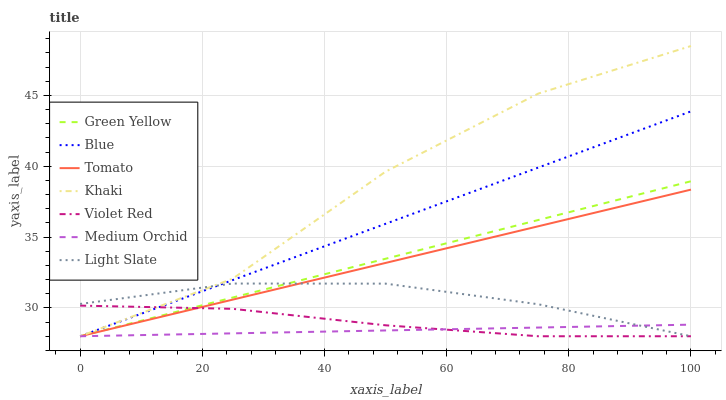Does Medium Orchid have the minimum area under the curve?
Answer yes or no. Yes. Does Khaki have the maximum area under the curve?
Answer yes or no. Yes. Does Tomato have the minimum area under the curve?
Answer yes or no. No. Does Tomato have the maximum area under the curve?
Answer yes or no. No. Is Blue the smoothest?
Answer yes or no. Yes. Is Khaki the roughest?
Answer yes or no. Yes. Is Tomato the smoothest?
Answer yes or no. No. Is Tomato the roughest?
Answer yes or no. No. Does Blue have the lowest value?
Answer yes or no. Yes. Does Khaki have the highest value?
Answer yes or no. Yes. Does Tomato have the highest value?
Answer yes or no. No. Does Blue intersect Green Yellow?
Answer yes or no. Yes. Is Blue less than Green Yellow?
Answer yes or no. No. Is Blue greater than Green Yellow?
Answer yes or no. No. 